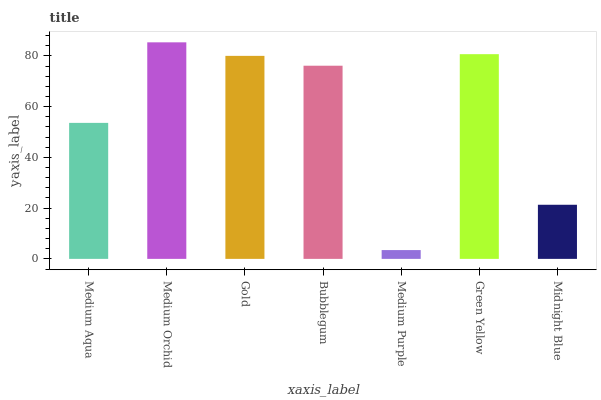Is Medium Purple the minimum?
Answer yes or no. Yes. Is Medium Orchid the maximum?
Answer yes or no. Yes. Is Gold the minimum?
Answer yes or no. No. Is Gold the maximum?
Answer yes or no. No. Is Medium Orchid greater than Gold?
Answer yes or no. Yes. Is Gold less than Medium Orchid?
Answer yes or no. Yes. Is Gold greater than Medium Orchid?
Answer yes or no. No. Is Medium Orchid less than Gold?
Answer yes or no. No. Is Bubblegum the high median?
Answer yes or no. Yes. Is Bubblegum the low median?
Answer yes or no. Yes. Is Medium Aqua the high median?
Answer yes or no. No. Is Medium Orchid the low median?
Answer yes or no. No. 